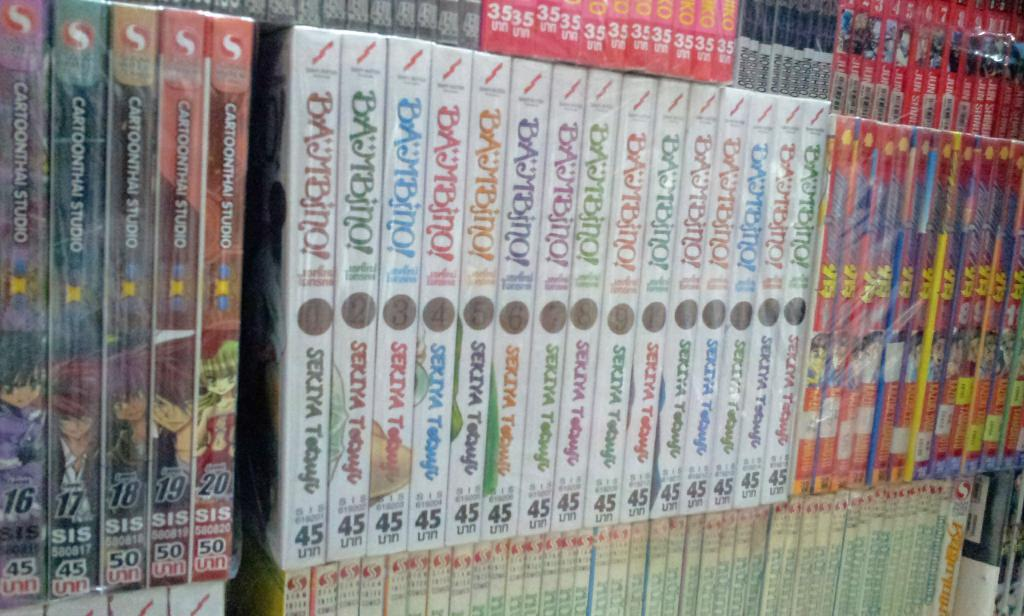<image>
Render a clear and concise summary of the photo. A collection of books with a title of Bambino. 